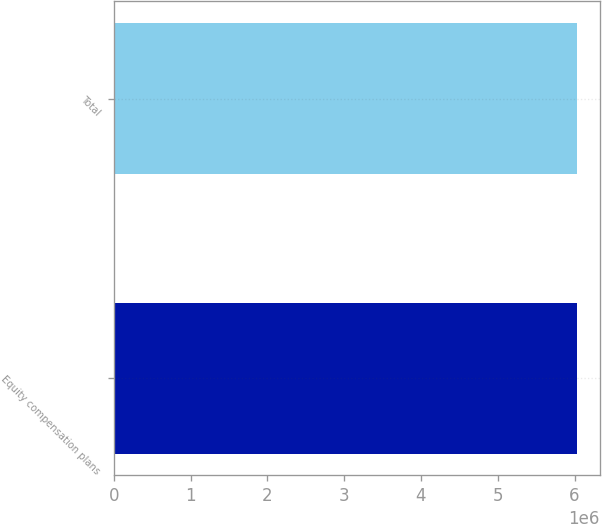Convert chart to OTSL. <chart><loc_0><loc_0><loc_500><loc_500><bar_chart><fcel>Equity compensation plans<fcel>Total<nl><fcel>6.02446e+06<fcel>6.02446e+06<nl></chart> 